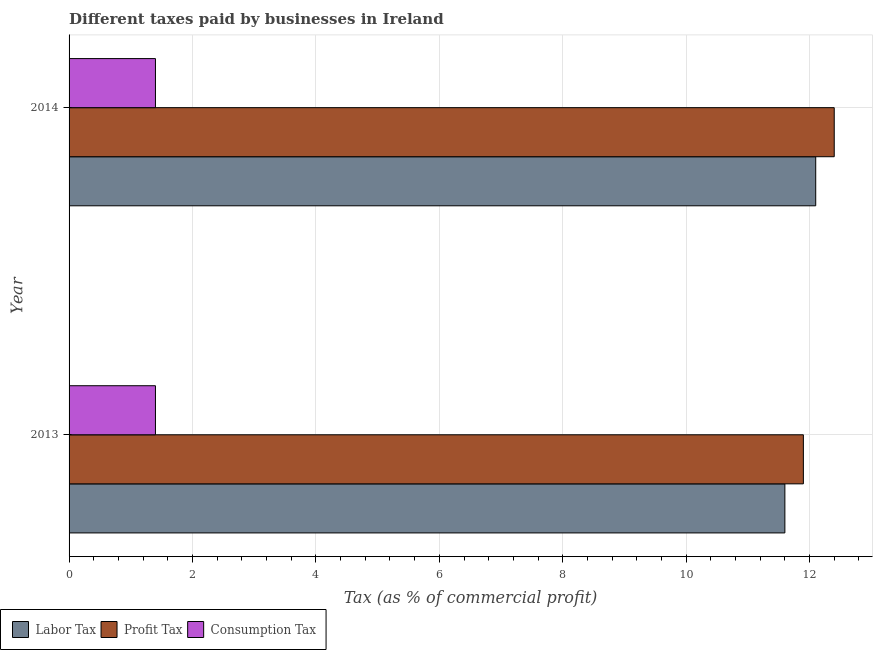How many different coloured bars are there?
Ensure brevity in your answer.  3. Are the number of bars per tick equal to the number of legend labels?
Offer a very short reply. Yes. What is the label of the 1st group of bars from the top?
Offer a very short reply. 2014. In how many cases, is the number of bars for a given year not equal to the number of legend labels?
Provide a succinct answer. 0. Across all years, what is the maximum percentage of labor tax?
Your answer should be compact. 12.1. Across all years, what is the minimum percentage of labor tax?
Offer a very short reply. 11.6. In which year was the percentage of profit tax minimum?
Make the answer very short. 2013. What is the total percentage of consumption tax in the graph?
Your answer should be compact. 2.8. What is the difference between the percentage of consumption tax in 2013 and that in 2014?
Your answer should be very brief. 0. What is the difference between the percentage of profit tax in 2013 and the percentage of labor tax in 2014?
Your answer should be compact. -0.2. What is the average percentage of labor tax per year?
Provide a succinct answer. 11.85. In the year 2013, what is the difference between the percentage of consumption tax and percentage of profit tax?
Your answer should be compact. -10.5. Is the difference between the percentage of labor tax in 2013 and 2014 greater than the difference between the percentage of consumption tax in 2013 and 2014?
Make the answer very short. No. In how many years, is the percentage of profit tax greater than the average percentage of profit tax taken over all years?
Make the answer very short. 1. What does the 1st bar from the top in 2014 represents?
Keep it short and to the point. Consumption Tax. What does the 1st bar from the bottom in 2013 represents?
Provide a short and direct response. Labor Tax. Is it the case that in every year, the sum of the percentage of labor tax and percentage of profit tax is greater than the percentage of consumption tax?
Provide a succinct answer. Yes. Are all the bars in the graph horizontal?
Provide a succinct answer. Yes. How many years are there in the graph?
Provide a succinct answer. 2. What is the difference between two consecutive major ticks on the X-axis?
Provide a succinct answer. 2. Are the values on the major ticks of X-axis written in scientific E-notation?
Ensure brevity in your answer.  No. Does the graph contain any zero values?
Your answer should be very brief. No. Where does the legend appear in the graph?
Ensure brevity in your answer.  Bottom left. How are the legend labels stacked?
Give a very brief answer. Horizontal. What is the title of the graph?
Provide a succinct answer. Different taxes paid by businesses in Ireland. What is the label or title of the X-axis?
Give a very brief answer. Tax (as % of commercial profit). What is the label or title of the Y-axis?
Offer a very short reply. Year. What is the Tax (as % of commercial profit) in Profit Tax in 2013?
Provide a succinct answer. 11.9. What is the Tax (as % of commercial profit) in Labor Tax in 2014?
Your answer should be compact. 12.1. What is the Tax (as % of commercial profit) in Profit Tax in 2014?
Ensure brevity in your answer.  12.4. What is the Tax (as % of commercial profit) in Consumption Tax in 2014?
Give a very brief answer. 1.4. Across all years, what is the maximum Tax (as % of commercial profit) in Labor Tax?
Offer a very short reply. 12.1. Across all years, what is the maximum Tax (as % of commercial profit) in Profit Tax?
Make the answer very short. 12.4. Across all years, what is the maximum Tax (as % of commercial profit) of Consumption Tax?
Your answer should be very brief. 1.4. Across all years, what is the minimum Tax (as % of commercial profit) in Labor Tax?
Keep it short and to the point. 11.6. Across all years, what is the minimum Tax (as % of commercial profit) of Profit Tax?
Your response must be concise. 11.9. What is the total Tax (as % of commercial profit) of Labor Tax in the graph?
Provide a succinct answer. 23.7. What is the total Tax (as % of commercial profit) of Profit Tax in the graph?
Make the answer very short. 24.3. What is the difference between the Tax (as % of commercial profit) of Profit Tax in 2013 and that in 2014?
Offer a terse response. -0.5. What is the difference between the Tax (as % of commercial profit) in Consumption Tax in 2013 and that in 2014?
Make the answer very short. 0. What is the difference between the Tax (as % of commercial profit) of Labor Tax in 2013 and the Tax (as % of commercial profit) of Consumption Tax in 2014?
Offer a very short reply. 10.2. What is the average Tax (as % of commercial profit) in Labor Tax per year?
Make the answer very short. 11.85. What is the average Tax (as % of commercial profit) in Profit Tax per year?
Make the answer very short. 12.15. What is the average Tax (as % of commercial profit) in Consumption Tax per year?
Your answer should be compact. 1.4. In the year 2013, what is the difference between the Tax (as % of commercial profit) of Labor Tax and Tax (as % of commercial profit) of Profit Tax?
Ensure brevity in your answer.  -0.3. In the year 2013, what is the difference between the Tax (as % of commercial profit) of Profit Tax and Tax (as % of commercial profit) of Consumption Tax?
Offer a very short reply. 10.5. In the year 2014, what is the difference between the Tax (as % of commercial profit) in Labor Tax and Tax (as % of commercial profit) in Profit Tax?
Give a very brief answer. -0.3. In the year 2014, what is the difference between the Tax (as % of commercial profit) of Labor Tax and Tax (as % of commercial profit) of Consumption Tax?
Make the answer very short. 10.7. What is the ratio of the Tax (as % of commercial profit) of Labor Tax in 2013 to that in 2014?
Ensure brevity in your answer.  0.96. What is the ratio of the Tax (as % of commercial profit) of Profit Tax in 2013 to that in 2014?
Your answer should be compact. 0.96. What is the difference between the highest and the second highest Tax (as % of commercial profit) in Labor Tax?
Ensure brevity in your answer.  0.5. What is the difference between the highest and the second highest Tax (as % of commercial profit) of Profit Tax?
Give a very brief answer. 0.5. What is the difference between the highest and the lowest Tax (as % of commercial profit) in Labor Tax?
Make the answer very short. 0.5. What is the difference between the highest and the lowest Tax (as % of commercial profit) in Profit Tax?
Give a very brief answer. 0.5. What is the difference between the highest and the lowest Tax (as % of commercial profit) in Consumption Tax?
Your response must be concise. 0. 